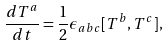<formula> <loc_0><loc_0><loc_500><loc_500>\frac { d { T ^ { a } } } { d t } = \frac { 1 } { 2 } { \epsilon } _ { a b c } [ T ^ { b } , T ^ { c } ] ,</formula> 